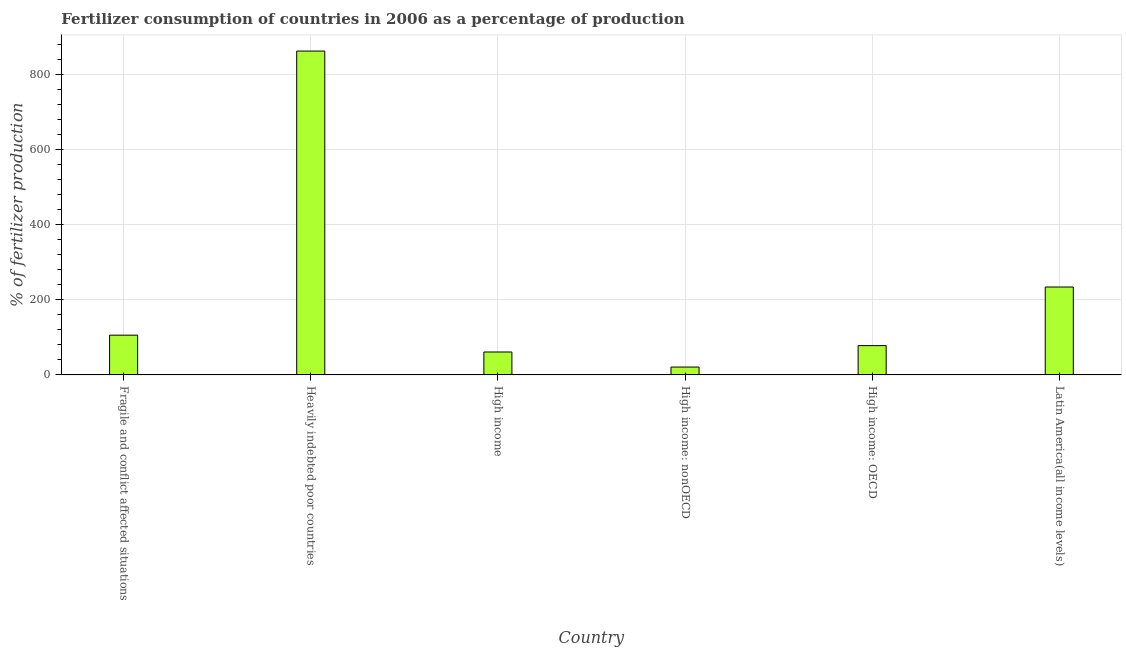Does the graph contain any zero values?
Your response must be concise. No. What is the title of the graph?
Offer a very short reply. Fertilizer consumption of countries in 2006 as a percentage of production. What is the label or title of the Y-axis?
Provide a short and direct response. % of fertilizer production. What is the amount of fertilizer consumption in High income: nonOECD?
Provide a succinct answer. 20.93. Across all countries, what is the maximum amount of fertilizer consumption?
Keep it short and to the point. 862.17. Across all countries, what is the minimum amount of fertilizer consumption?
Make the answer very short. 20.93. In which country was the amount of fertilizer consumption maximum?
Make the answer very short. Heavily indebted poor countries. In which country was the amount of fertilizer consumption minimum?
Provide a succinct answer. High income: nonOECD. What is the sum of the amount of fertilizer consumption?
Offer a terse response. 1361.98. What is the difference between the amount of fertilizer consumption in Fragile and conflict affected situations and Heavily indebted poor countries?
Offer a very short reply. -756.33. What is the average amount of fertilizer consumption per country?
Keep it short and to the point. 227. What is the median amount of fertilizer consumption?
Provide a short and direct response. 91.91. What is the ratio of the amount of fertilizer consumption in Fragile and conflict affected situations to that in High income?
Your answer should be compact. 1.73. Is the difference between the amount of fertilizer consumption in High income: OECD and Latin America(all income levels) greater than the difference between any two countries?
Your answer should be very brief. No. What is the difference between the highest and the second highest amount of fertilizer consumption?
Offer a very short reply. 628.12. Is the sum of the amount of fertilizer consumption in High income: OECD and High income: nonOECD greater than the maximum amount of fertilizer consumption across all countries?
Provide a short and direct response. No. What is the difference between the highest and the lowest amount of fertilizer consumption?
Give a very brief answer. 841.24. In how many countries, is the amount of fertilizer consumption greater than the average amount of fertilizer consumption taken over all countries?
Make the answer very short. 2. Are all the bars in the graph horizontal?
Give a very brief answer. No. How many countries are there in the graph?
Ensure brevity in your answer.  6. What is the % of fertilizer production of Fragile and conflict affected situations?
Provide a short and direct response. 105.84. What is the % of fertilizer production in Heavily indebted poor countries?
Your answer should be very brief. 862.17. What is the % of fertilizer production in High income?
Provide a short and direct response. 61.02. What is the % of fertilizer production in High income: nonOECD?
Give a very brief answer. 20.93. What is the % of fertilizer production of High income: OECD?
Provide a short and direct response. 77.98. What is the % of fertilizer production of Latin America(all income levels)?
Your response must be concise. 234.04. What is the difference between the % of fertilizer production in Fragile and conflict affected situations and Heavily indebted poor countries?
Your answer should be very brief. -756.33. What is the difference between the % of fertilizer production in Fragile and conflict affected situations and High income?
Provide a succinct answer. 44.82. What is the difference between the % of fertilizer production in Fragile and conflict affected situations and High income: nonOECD?
Offer a very short reply. 84.91. What is the difference between the % of fertilizer production in Fragile and conflict affected situations and High income: OECD?
Provide a short and direct response. 27.86. What is the difference between the % of fertilizer production in Fragile and conflict affected situations and Latin America(all income levels)?
Provide a short and direct response. -128.2. What is the difference between the % of fertilizer production in Heavily indebted poor countries and High income?
Offer a very short reply. 801.14. What is the difference between the % of fertilizer production in Heavily indebted poor countries and High income: nonOECD?
Your answer should be very brief. 841.24. What is the difference between the % of fertilizer production in Heavily indebted poor countries and High income: OECD?
Offer a very short reply. 784.18. What is the difference between the % of fertilizer production in Heavily indebted poor countries and Latin America(all income levels)?
Offer a very short reply. 628.12. What is the difference between the % of fertilizer production in High income and High income: nonOECD?
Offer a terse response. 40.1. What is the difference between the % of fertilizer production in High income and High income: OECD?
Your answer should be very brief. -16.96. What is the difference between the % of fertilizer production in High income and Latin America(all income levels)?
Your answer should be very brief. -173.02. What is the difference between the % of fertilizer production in High income: nonOECD and High income: OECD?
Offer a very short reply. -57.06. What is the difference between the % of fertilizer production in High income: nonOECD and Latin America(all income levels)?
Give a very brief answer. -213.12. What is the difference between the % of fertilizer production in High income: OECD and Latin America(all income levels)?
Give a very brief answer. -156.06. What is the ratio of the % of fertilizer production in Fragile and conflict affected situations to that in Heavily indebted poor countries?
Give a very brief answer. 0.12. What is the ratio of the % of fertilizer production in Fragile and conflict affected situations to that in High income?
Offer a terse response. 1.73. What is the ratio of the % of fertilizer production in Fragile and conflict affected situations to that in High income: nonOECD?
Give a very brief answer. 5.06. What is the ratio of the % of fertilizer production in Fragile and conflict affected situations to that in High income: OECD?
Your answer should be compact. 1.36. What is the ratio of the % of fertilizer production in Fragile and conflict affected situations to that in Latin America(all income levels)?
Offer a terse response. 0.45. What is the ratio of the % of fertilizer production in Heavily indebted poor countries to that in High income?
Keep it short and to the point. 14.13. What is the ratio of the % of fertilizer production in Heavily indebted poor countries to that in High income: nonOECD?
Your answer should be compact. 41.2. What is the ratio of the % of fertilizer production in Heavily indebted poor countries to that in High income: OECD?
Your answer should be compact. 11.06. What is the ratio of the % of fertilizer production in Heavily indebted poor countries to that in Latin America(all income levels)?
Make the answer very short. 3.68. What is the ratio of the % of fertilizer production in High income to that in High income: nonOECD?
Make the answer very short. 2.92. What is the ratio of the % of fertilizer production in High income to that in High income: OECD?
Your answer should be very brief. 0.78. What is the ratio of the % of fertilizer production in High income to that in Latin America(all income levels)?
Your response must be concise. 0.26. What is the ratio of the % of fertilizer production in High income: nonOECD to that in High income: OECD?
Keep it short and to the point. 0.27. What is the ratio of the % of fertilizer production in High income: nonOECD to that in Latin America(all income levels)?
Ensure brevity in your answer.  0.09. What is the ratio of the % of fertilizer production in High income: OECD to that in Latin America(all income levels)?
Offer a very short reply. 0.33. 